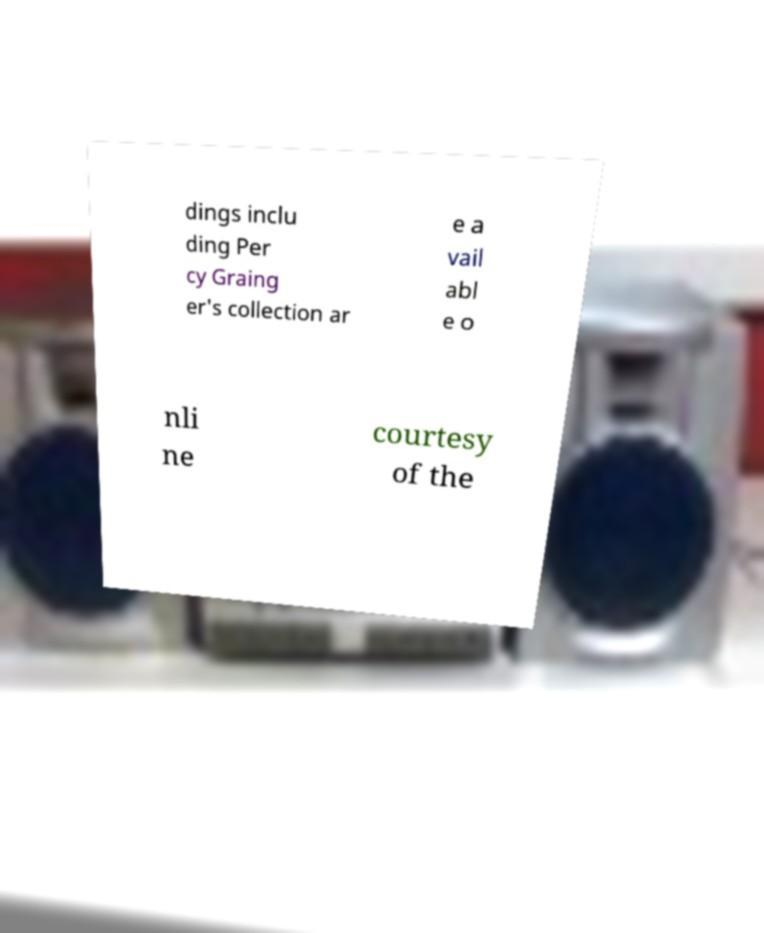Can you read and provide the text displayed in the image?This photo seems to have some interesting text. Can you extract and type it out for me? dings inclu ding Per cy Graing er's collection ar e a vail abl e o nli ne courtesy of the 